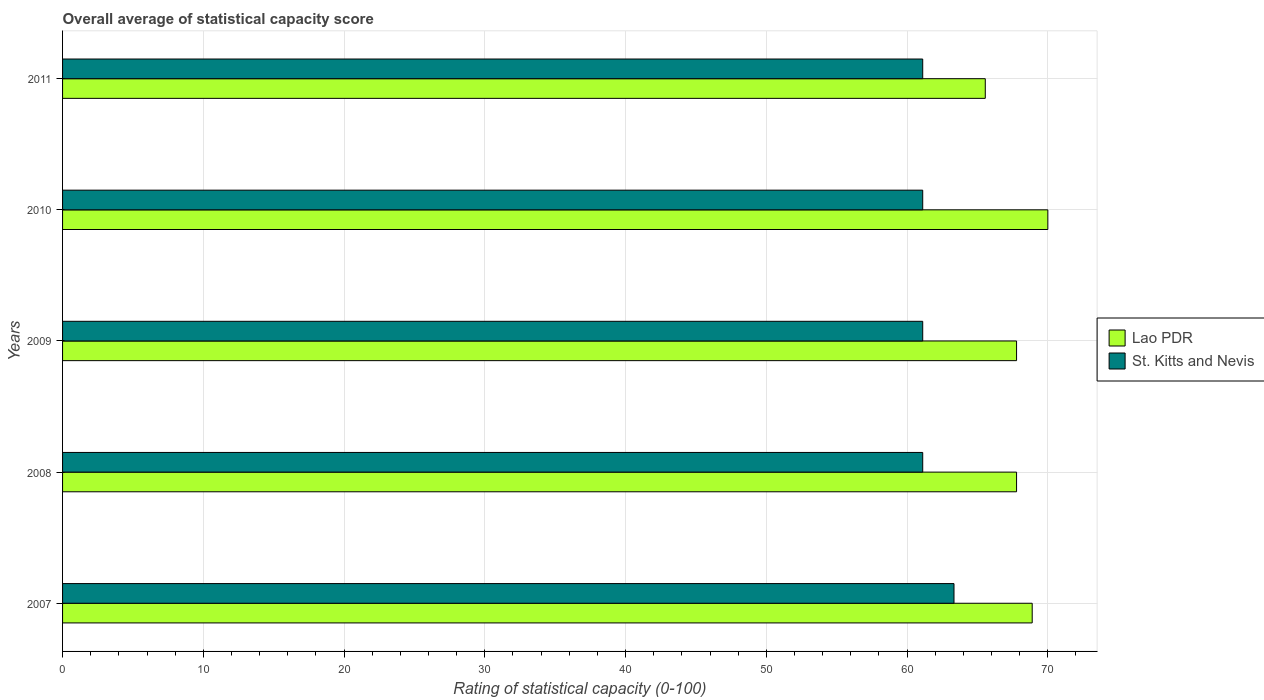Are the number of bars on each tick of the Y-axis equal?
Keep it short and to the point. Yes. How many bars are there on the 3rd tick from the top?
Your answer should be very brief. 2. What is the label of the 5th group of bars from the top?
Your answer should be compact. 2007. In how many cases, is the number of bars for a given year not equal to the number of legend labels?
Offer a very short reply. 0. What is the rating of statistical capacity in St. Kitts and Nevis in 2007?
Your answer should be very brief. 63.33. Across all years, what is the maximum rating of statistical capacity in St. Kitts and Nevis?
Give a very brief answer. 63.33. Across all years, what is the minimum rating of statistical capacity in Lao PDR?
Offer a very short reply. 65.56. In which year was the rating of statistical capacity in Lao PDR maximum?
Your answer should be compact. 2010. In which year was the rating of statistical capacity in St. Kitts and Nevis minimum?
Offer a terse response. 2008. What is the total rating of statistical capacity in St. Kitts and Nevis in the graph?
Provide a short and direct response. 307.78. What is the difference between the rating of statistical capacity in St. Kitts and Nevis in 2007 and that in 2011?
Your answer should be compact. 2.22. What is the difference between the rating of statistical capacity in Lao PDR in 2009 and the rating of statistical capacity in St. Kitts and Nevis in 2011?
Your response must be concise. 6.67. What is the average rating of statistical capacity in Lao PDR per year?
Provide a short and direct response. 68. In the year 2010, what is the difference between the rating of statistical capacity in St. Kitts and Nevis and rating of statistical capacity in Lao PDR?
Your answer should be compact. -8.89. In how many years, is the rating of statistical capacity in Lao PDR greater than 66 ?
Your response must be concise. 4. What is the ratio of the rating of statistical capacity in St. Kitts and Nevis in 2007 to that in 2008?
Your response must be concise. 1.04. What is the difference between the highest and the second highest rating of statistical capacity in St. Kitts and Nevis?
Offer a terse response. 2.22. What is the difference between the highest and the lowest rating of statistical capacity in Lao PDR?
Your response must be concise. 4.44. In how many years, is the rating of statistical capacity in St. Kitts and Nevis greater than the average rating of statistical capacity in St. Kitts and Nevis taken over all years?
Ensure brevity in your answer.  1. What does the 2nd bar from the top in 2008 represents?
Ensure brevity in your answer.  Lao PDR. What does the 1st bar from the bottom in 2011 represents?
Keep it short and to the point. Lao PDR. How many bars are there?
Ensure brevity in your answer.  10. How many years are there in the graph?
Your answer should be very brief. 5. Are the values on the major ticks of X-axis written in scientific E-notation?
Make the answer very short. No. Does the graph contain any zero values?
Ensure brevity in your answer.  No. Where does the legend appear in the graph?
Ensure brevity in your answer.  Center right. What is the title of the graph?
Your answer should be compact. Overall average of statistical capacity score. Does "Trinidad and Tobago" appear as one of the legend labels in the graph?
Offer a terse response. No. What is the label or title of the X-axis?
Keep it short and to the point. Rating of statistical capacity (0-100). What is the label or title of the Y-axis?
Give a very brief answer. Years. What is the Rating of statistical capacity (0-100) in Lao PDR in 2007?
Ensure brevity in your answer.  68.89. What is the Rating of statistical capacity (0-100) in St. Kitts and Nevis in 2007?
Your response must be concise. 63.33. What is the Rating of statistical capacity (0-100) of Lao PDR in 2008?
Ensure brevity in your answer.  67.78. What is the Rating of statistical capacity (0-100) of St. Kitts and Nevis in 2008?
Ensure brevity in your answer.  61.11. What is the Rating of statistical capacity (0-100) in Lao PDR in 2009?
Provide a succinct answer. 67.78. What is the Rating of statistical capacity (0-100) in St. Kitts and Nevis in 2009?
Your answer should be compact. 61.11. What is the Rating of statistical capacity (0-100) in Lao PDR in 2010?
Offer a terse response. 70. What is the Rating of statistical capacity (0-100) in St. Kitts and Nevis in 2010?
Make the answer very short. 61.11. What is the Rating of statistical capacity (0-100) in Lao PDR in 2011?
Offer a very short reply. 65.56. What is the Rating of statistical capacity (0-100) in St. Kitts and Nevis in 2011?
Make the answer very short. 61.11. Across all years, what is the maximum Rating of statistical capacity (0-100) in Lao PDR?
Your answer should be compact. 70. Across all years, what is the maximum Rating of statistical capacity (0-100) in St. Kitts and Nevis?
Ensure brevity in your answer.  63.33. Across all years, what is the minimum Rating of statistical capacity (0-100) in Lao PDR?
Provide a short and direct response. 65.56. Across all years, what is the minimum Rating of statistical capacity (0-100) of St. Kitts and Nevis?
Your answer should be very brief. 61.11. What is the total Rating of statistical capacity (0-100) of Lao PDR in the graph?
Your response must be concise. 340. What is the total Rating of statistical capacity (0-100) in St. Kitts and Nevis in the graph?
Your answer should be very brief. 307.78. What is the difference between the Rating of statistical capacity (0-100) in St. Kitts and Nevis in 2007 and that in 2008?
Your answer should be very brief. 2.22. What is the difference between the Rating of statistical capacity (0-100) of St. Kitts and Nevis in 2007 and that in 2009?
Give a very brief answer. 2.22. What is the difference between the Rating of statistical capacity (0-100) in Lao PDR in 2007 and that in 2010?
Give a very brief answer. -1.11. What is the difference between the Rating of statistical capacity (0-100) in St. Kitts and Nevis in 2007 and that in 2010?
Provide a succinct answer. 2.22. What is the difference between the Rating of statistical capacity (0-100) in Lao PDR in 2007 and that in 2011?
Your response must be concise. 3.33. What is the difference between the Rating of statistical capacity (0-100) in St. Kitts and Nevis in 2007 and that in 2011?
Provide a short and direct response. 2.22. What is the difference between the Rating of statistical capacity (0-100) of Lao PDR in 2008 and that in 2009?
Your answer should be compact. 0. What is the difference between the Rating of statistical capacity (0-100) in Lao PDR in 2008 and that in 2010?
Make the answer very short. -2.22. What is the difference between the Rating of statistical capacity (0-100) in Lao PDR in 2008 and that in 2011?
Ensure brevity in your answer.  2.22. What is the difference between the Rating of statistical capacity (0-100) of Lao PDR in 2009 and that in 2010?
Give a very brief answer. -2.22. What is the difference between the Rating of statistical capacity (0-100) in St. Kitts and Nevis in 2009 and that in 2010?
Provide a short and direct response. 0. What is the difference between the Rating of statistical capacity (0-100) in Lao PDR in 2009 and that in 2011?
Ensure brevity in your answer.  2.22. What is the difference between the Rating of statistical capacity (0-100) of St. Kitts and Nevis in 2009 and that in 2011?
Make the answer very short. 0. What is the difference between the Rating of statistical capacity (0-100) of Lao PDR in 2010 and that in 2011?
Offer a very short reply. 4.44. What is the difference between the Rating of statistical capacity (0-100) in St. Kitts and Nevis in 2010 and that in 2011?
Provide a short and direct response. 0. What is the difference between the Rating of statistical capacity (0-100) in Lao PDR in 2007 and the Rating of statistical capacity (0-100) in St. Kitts and Nevis in 2008?
Offer a very short reply. 7.78. What is the difference between the Rating of statistical capacity (0-100) of Lao PDR in 2007 and the Rating of statistical capacity (0-100) of St. Kitts and Nevis in 2009?
Offer a very short reply. 7.78. What is the difference between the Rating of statistical capacity (0-100) of Lao PDR in 2007 and the Rating of statistical capacity (0-100) of St. Kitts and Nevis in 2010?
Provide a short and direct response. 7.78. What is the difference between the Rating of statistical capacity (0-100) in Lao PDR in 2007 and the Rating of statistical capacity (0-100) in St. Kitts and Nevis in 2011?
Your answer should be very brief. 7.78. What is the difference between the Rating of statistical capacity (0-100) in Lao PDR in 2008 and the Rating of statistical capacity (0-100) in St. Kitts and Nevis in 2009?
Offer a very short reply. 6.67. What is the difference between the Rating of statistical capacity (0-100) in Lao PDR in 2008 and the Rating of statistical capacity (0-100) in St. Kitts and Nevis in 2010?
Make the answer very short. 6.67. What is the difference between the Rating of statistical capacity (0-100) of Lao PDR in 2009 and the Rating of statistical capacity (0-100) of St. Kitts and Nevis in 2010?
Ensure brevity in your answer.  6.67. What is the difference between the Rating of statistical capacity (0-100) of Lao PDR in 2010 and the Rating of statistical capacity (0-100) of St. Kitts and Nevis in 2011?
Make the answer very short. 8.89. What is the average Rating of statistical capacity (0-100) in St. Kitts and Nevis per year?
Make the answer very short. 61.56. In the year 2007, what is the difference between the Rating of statistical capacity (0-100) in Lao PDR and Rating of statistical capacity (0-100) in St. Kitts and Nevis?
Offer a very short reply. 5.56. In the year 2008, what is the difference between the Rating of statistical capacity (0-100) in Lao PDR and Rating of statistical capacity (0-100) in St. Kitts and Nevis?
Your answer should be compact. 6.67. In the year 2010, what is the difference between the Rating of statistical capacity (0-100) of Lao PDR and Rating of statistical capacity (0-100) of St. Kitts and Nevis?
Ensure brevity in your answer.  8.89. In the year 2011, what is the difference between the Rating of statistical capacity (0-100) in Lao PDR and Rating of statistical capacity (0-100) in St. Kitts and Nevis?
Offer a terse response. 4.44. What is the ratio of the Rating of statistical capacity (0-100) of Lao PDR in 2007 to that in 2008?
Make the answer very short. 1.02. What is the ratio of the Rating of statistical capacity (0-100) in St. Kitts and Nevis in 2007 to that in 2008?
Your answer should be compact. 1.04. What is the ratio of the Rating of statistical capacity (0-100) in Lao PDR in 2007 to that in 2009?
Offer a terse response. 1.02. What is the ratio of the Rating of statistical capacity (0-100) of St. Kitts and Nevis in 2007 to that in 2009?
Provide a succinct answer. 1.04. What is the ratio of the Rating of statistical capacity (0-100) in Lao PDR in 2007 to that in 2010?
Offer a very short reply. 0.98. What is the ratio of the Rating of statistical capacity (0-100) of St. Kitts and Nevis in 2007 to that in 2010?
Your answer should be compact. 1.04. What is the ratio of the Rating of statistical capacity (0-100) in Lao PDR in 2007 to that in 2011?
Your response must be concise. 1.05. What is the ratio of the Rating of statistical capacity (0-100) of St. Kitts and Nevis in 2007 to that in 2011?
Make the answer very short. 1.04. What is the ratio of the Rating of statistical capacity (0-100) in Lao PDR in 2008 to that in 2010?
Keep it short and to the point. 0.97. What is the ratio of the Rating of statistical capacity (0-100) in Lao PDR in 2008 to that in 2011?
Provide a succinct answer. 1.03. What is the ratio of the Rating of statistical capacity (0-100) of St. Kitts and Nevis in 2008 to that in 2011?
Your answer should be very brief. 1. What is the ratio of the Rating of statistical capacity (0-100) in Lao PDR in 2009 to that in 2010?
Provide a short and direct response. 0.97. What is the ratio of the Rating of statistical capacity (0-100) of St. Kitts and Nevis in 2009 to that in 2010?
Give a very brief answer. 1. What is the ratio of the Rating of statistical capacity (0-100) of Lao PDR in 2009 to that in 2011?
Your answer should be compact. 1.03. What is the ratio of the Rating of statistical capacity (0-100) of Lao PDR in 2010 to that in 2011?
Provide a succinct answer. 1.07. What is the ratio of the Rating of statistical capacity (0-100) in St. Kitts and Nevis in 2010 to that in 2011?
Your answer should be compact. 1. What is the difference between the highest and the second highest Rating of statistical capacity (0-100) of Lao PDR?
Provide a short and direct response. 1.11. What is the difference between the highest and the second highest Rating of statistical capacity (0-100) of St. Kitts and Nevis?
Ensure brevity in your answer.  2.22. What is the difference between the highest and the lowest Rating of statistical capacity (0-100) in Lao PDR?
Your answer should be very brief. 4.44. What is the difference between the highest and the lowest Rating of statistical capacity (0-100) of St. Kitts and Nevis?
Offer a terse response. 2.22. 